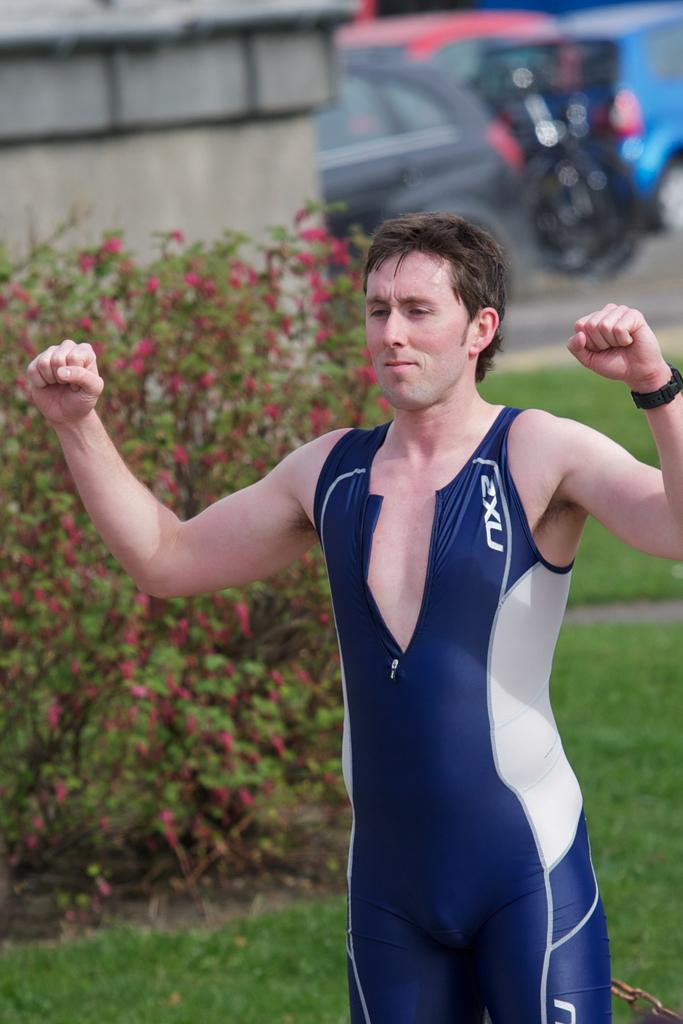What is the main subject in the front of the image? There is a person standing in the front of the image. What can be seen in the background of the image? There are flowers, a wall, and vehicles in the background of the image. What type of vegetation is present on the ground in the image? There is grass on the ground in the image. What type of invention is being demonstrated by the person in the image? There is no invention being demonstrated by the person in the image; they are simply standing. Can you see any mountains in the background of the image? No, there are no mountains visible in the image. 